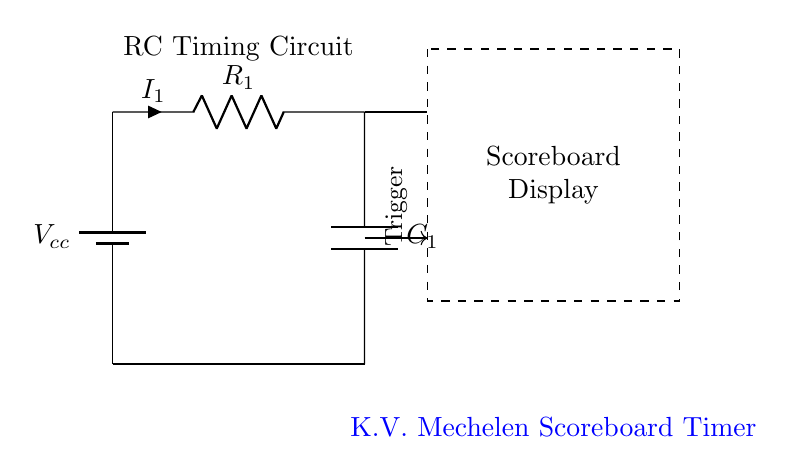What is the power supply voltage in the circuit? The circuit shows a battery labeled Vcc, which represents the power supply voltage. The exact value is not specified in the diagram, but it is typically a standard voltage like five volts or twelve volts.
Answer: Vcc What component limits the current in this circuit? The resistor, labeled R1, is the component that limits the current flowing through the circuit. It does this by providing resistance according to Ohm's law.
Answer: R1 What is the role of the capacitor in this circuit? The capacitor, labeled C1, is responsible for storing electrical energy and releasing it over time, which is essential for timing applications. It works in conjunction with the resistor to create a time constant for the circuit.
Answer: Timing What is the main function of this circuit? The primary purpose of the circuit is to provide timing control for the scoreboard display. The RC network creates delays that can be used to synchronize updates to the display.
Answer: Timing control How does the time constant of the circuit affect the operation? The time constant, which is the product of resistance and capacitance (R1 * C1), determines how quickly the capacitor charges and discharges. A larger time constant will mean a slower charge/discharge rate, affecting the timing intervals for the scoreboard.
Answer: Determines timing intervals What is the output of the RC timing circuit used for? The output from this RC timing circuit serves as a trigger signal for the scoreboard display, signaling when to update or refresh the displayed information.
Answer: Trigger signal What happens if the value of capacitance increases? If the capacitance (C1) increases, the time constant will also increase, leading to longer charge and discharge times. This means the timing intervals for the scoreboard's operation will extend, resulting in slower updates.
Answer: Longer intervals 